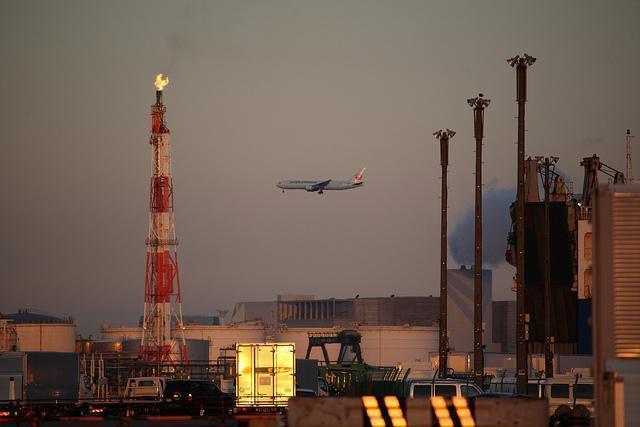What is coming out of the red and white tower?
Choose the right answer from the provided options to respond to the question.
Options: Water, smoke, people, fire. Fire. 